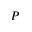<formula> <loc_0><loc_0><loc_500><loc_500>P</formula> 